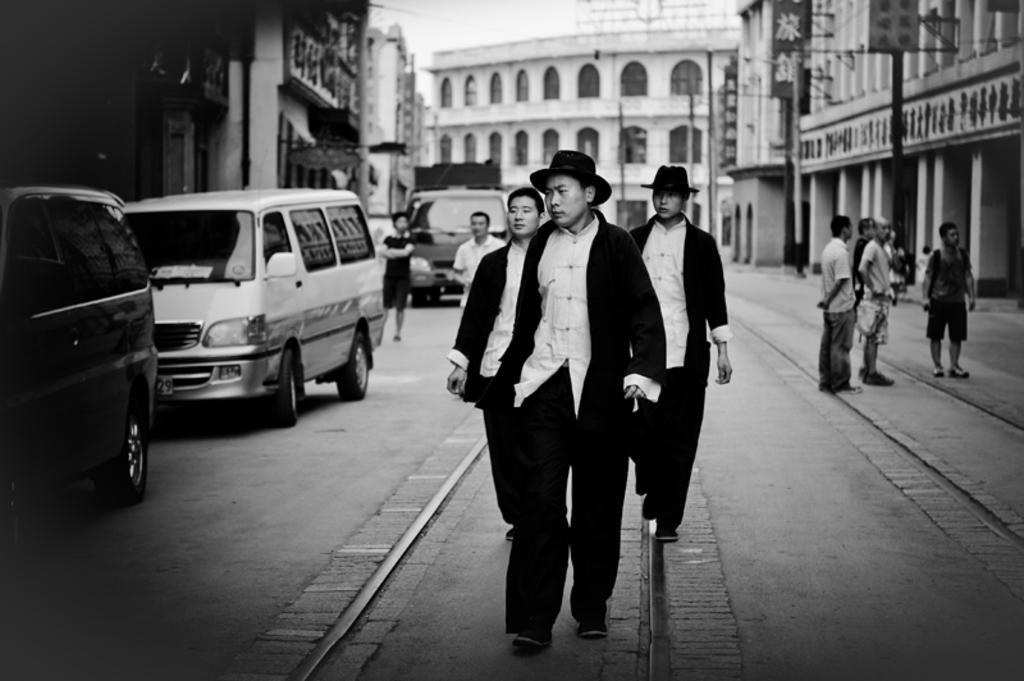Could you give a brief overview of what you see in this image? In this image, we can see some people walking in the middle, there are some people standing on the right side, we can see some cars on the left side, there are some buildings and we can see some windows on the buildings, at the top we can see the sky. 